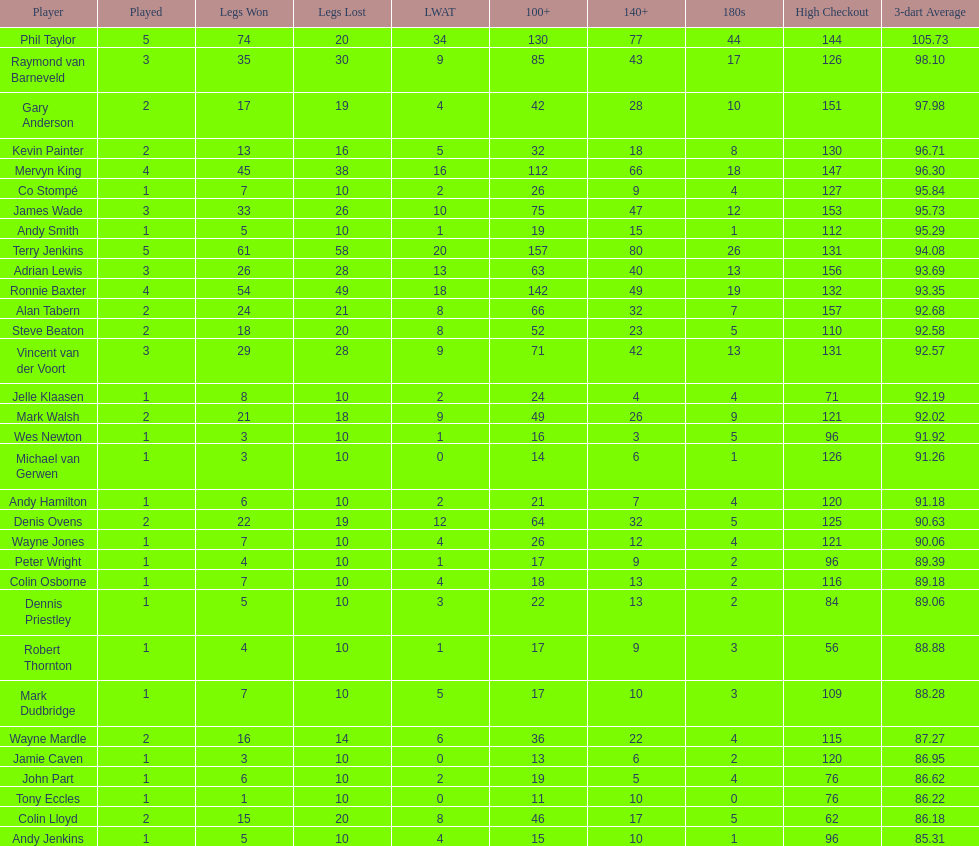How many players have taken part in more than three games in total? 4. 